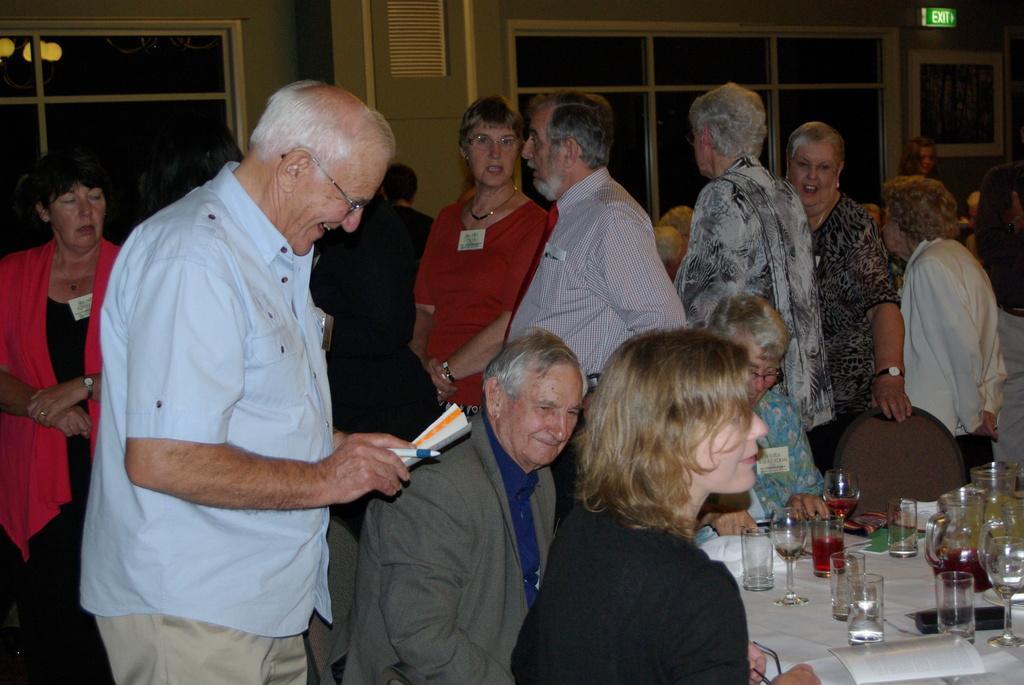Describe this image in one or two sentences. In this picture I can see few people are standing and few are sitting in the chairs and I can see glasses and few glass jugs on the table and I can see a man holding papers and a pen in his hand and I can see a photo frame on the wall and I can see glass window and I can see reflection of lights on the glass. 